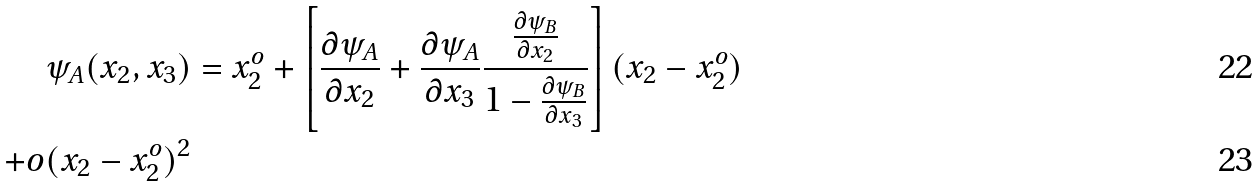<formula> <loc_0><loc_0><loc_500><loc_500>\psi _ { A } ( x _ { 2 } , x _ { 3 } ) & = x _ { 2 } ^ { o } + \left [ \frac { \partial \psi _ { A } } { \partial x _ { 2 } } + \frac { \partial \psi _ { A } } { \partial x _ { 3 } } \frac { \frac { \partial \psi _ { B } } { \partial x _ { 2 } } } { 1 - \frac { \partial \psi _ { B } } { \partial x _ { 3 } } } \right ] ( x _ { 2 } - x _ { 2 } ^ { o } ) \\ + o ( x _ { 2 } - x _ { 2 } ^ { o } ) ^ { 2 }</formula> 